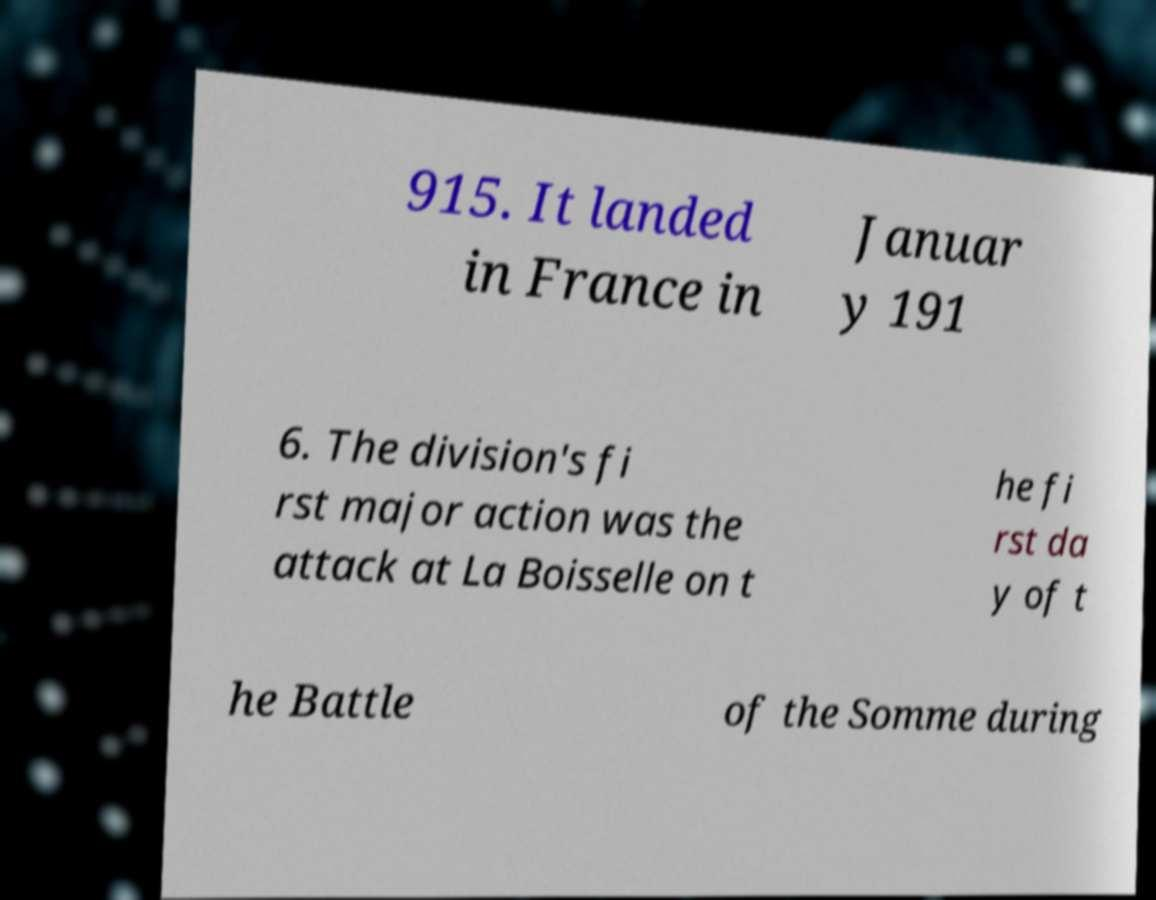Could you assist in decoding the text presented in this image and type it out clearly? 915. It landed in France in Januar y 191 6. The division's fi rst major action was the attack at La Boisselle on t he fi rst da y of t he Battle of the Somme during 